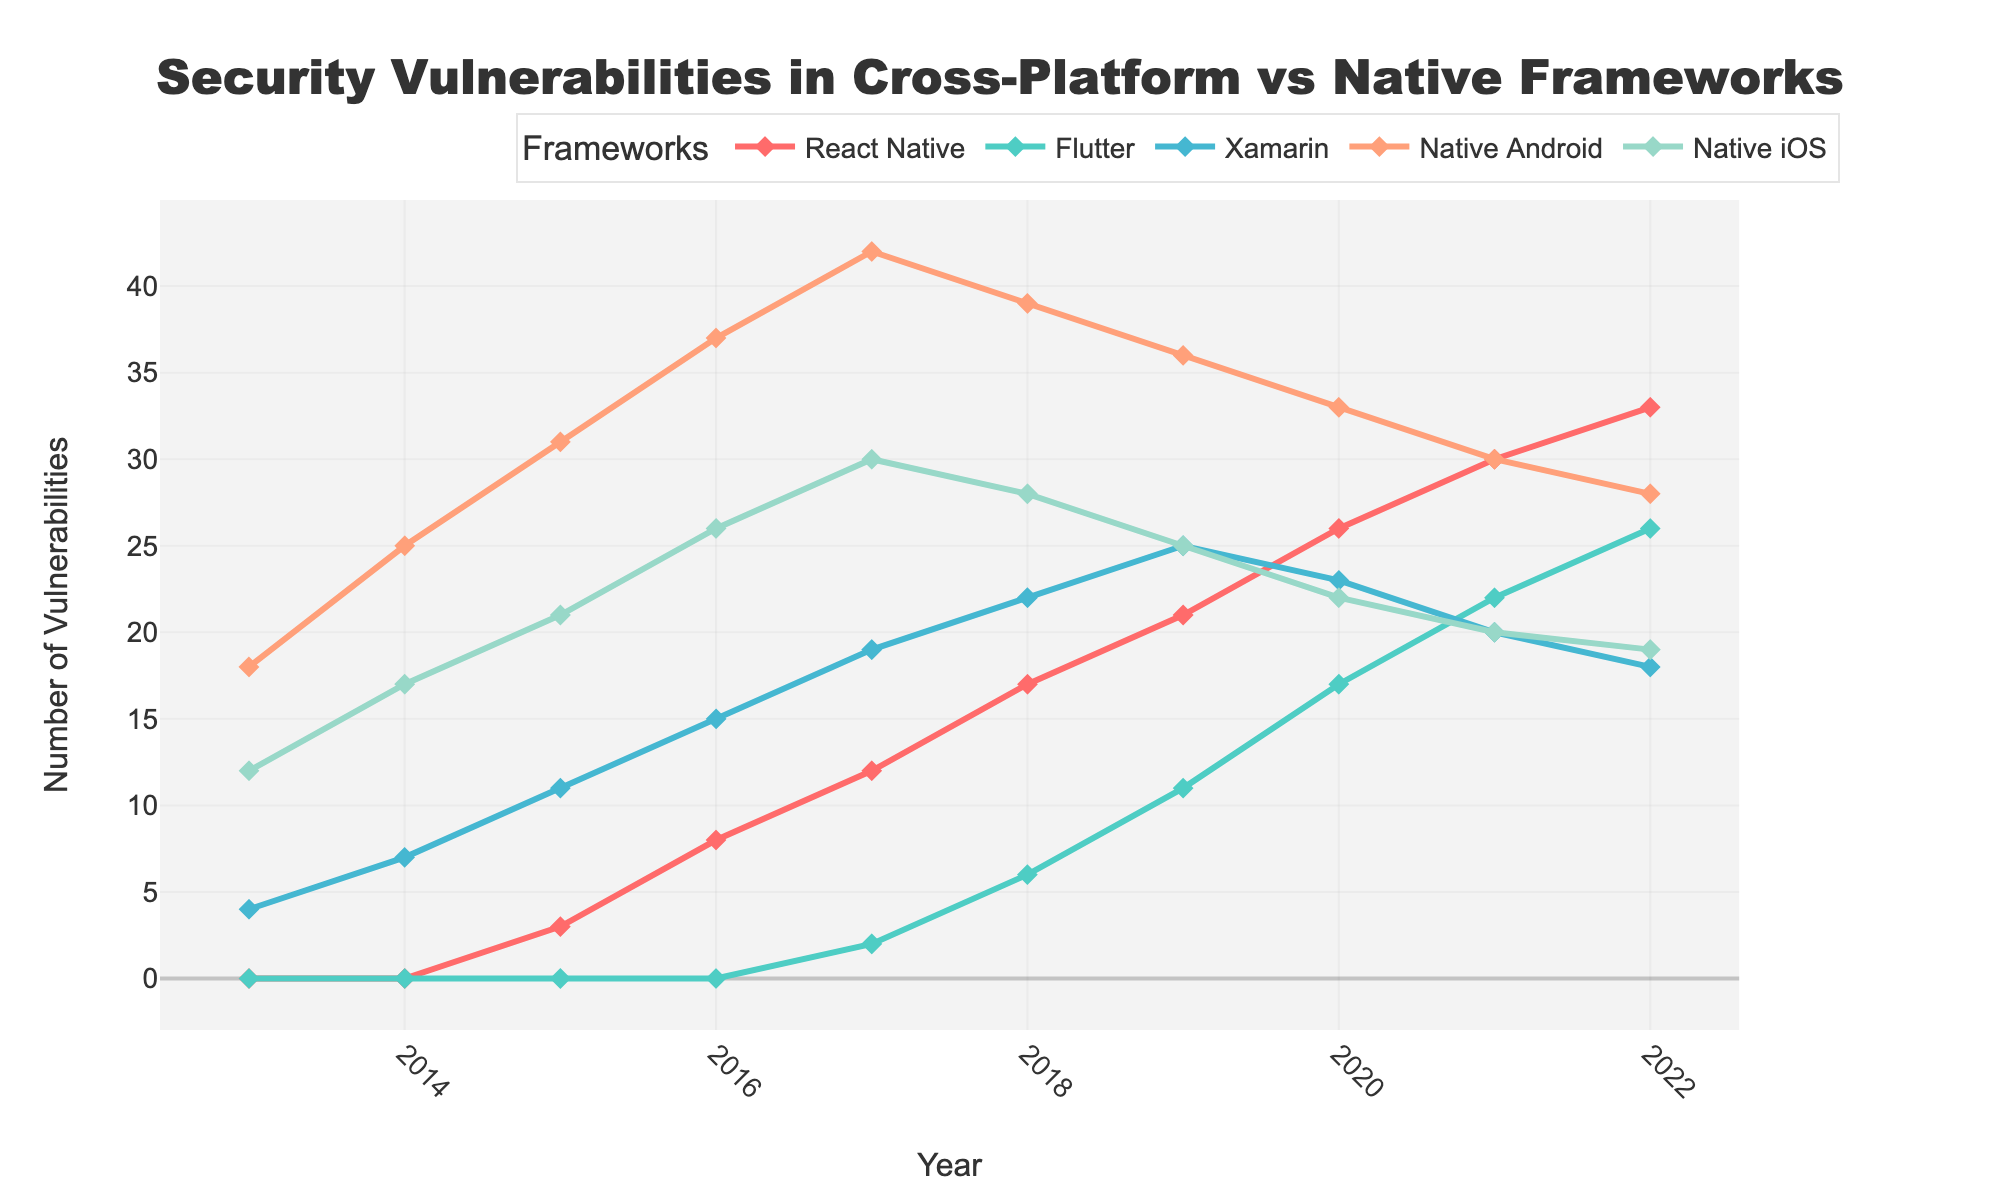What's the total number of vulnerabilities discovered in Native Android and Native iOS in 2016? First, find the number of vulnerabilities in Native Android (37) and Native iOS (26) for 2016. Sum these numbers: 37 + 26 = 63
Answer: 63 Did Flutter have more vulnerabilities than Xamarin in 2020? Check the number of vulnerabilities for both Flutter (17) and Xamarin (23) in 2020. Compare the numbers: 17 < 23, so Flutter had fewer vulnerabilities than Xamarin
Answer: No Which framework saw the highest increase in vulnerabilities from 2013 to 2022? Calculate the difference from 2013 to 2022 for each framework. React Native: 33-0=33, Flutter: 26-0=26, Xamarin: 18-4=14, Native Android: 28-18=10, Native iOS: 19-12=7. React Native saw the highest increase
Answer: React Native What's the average number of vulnerabilities for React Native over the decade? Sum the vulnerabilities for React Native from 2013 to 2022: 0+0+3+8+12+17+21+26+30+33 = 150. Divide by the number of years (10): 150/10 = 15
Answer: 15 By how many points did the vulnerabilities in Native Android decrease from its peak in 2017 to 2022? Native Android peaked at 42 in 2017 and had 28 vulnerabilities in 2022. Calculate the decrease: 42 - 28 = 14
Answer: 14 Which framework had the least vulnerabilities in 2019? Compare the vulnerabilities in 2019: React Native: 21, Flutter: 11, Xamarin: 25, Native Android: 36, Native iOS: 25. Flutter had the least
Answer: Flutter What visual marker is used to represent the data points in the figure? The figure uses diamond-shaped markers on each line to represent the data points
Answer: Diamond How many vulnerabilities were discovered collectively for all frameworks in 2021? Sum the vulnerabilities for all frameworks in 2021: React Native: 30, Flutter: 22, Xamarin: 20, Native Android: 30, Native iOS: 20. Total: 30+22+20+30+20 = 122
Answer: 122 What's the maximum number of vulnerabilities observed for Flutter up to 2022? Look at the vulnerabilities for Flutter from 2013 to 2022 and find the maximum number, which is 26 in 2022
Answer: 26 How did the number of vulnerabilities for Xamarin change from 2020 to 2022? Observe the vulnerabilities for Xamarin: 2020: 23, 2021: 20, 2022: 18. It decreased by 5 from 2020 to 2022 (23-18=5)
Answer: Decreased by 5 